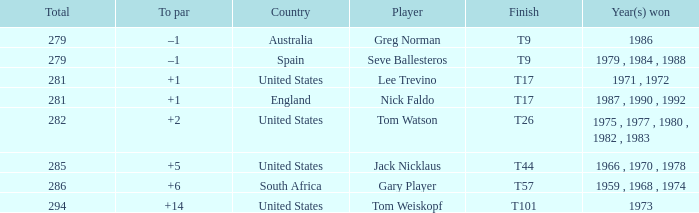Which player is from Australia? Greg Norman. 